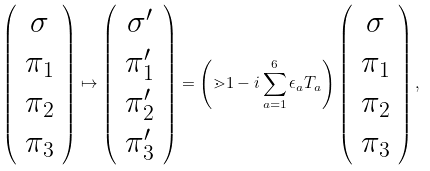Convert formula to latex. <formula><loc_0><loc_0><loc_500><loc_500>\left ( \begin{array} { c } \sigma \\ \pi _ { 1 } \\ \pi _ { 2 } \\ \pi _ { 3 } \end{array} \right ) \mapsto \left ( \begin{array} { c } \sigma ^ { \prime } \\ \pi ^ { \prime } _ { 1 } \\ \pi ^ { \prime } _ { 2 } \\ \pi ^ { \prime } _ { 3 } \end{array} \right ) = \left ( { \mathbb { m } 1 } - i \sum _ { a = 1 } ^ { 6 } \epsilon _ { a } T _ { a } \right ) \left ( \begin{array} { c } \sigma \\ \pi _ { 1 } \\ \pi _ { 2 } \\ \pi _ { 3 } \end{array} \right ) ,</formula> 